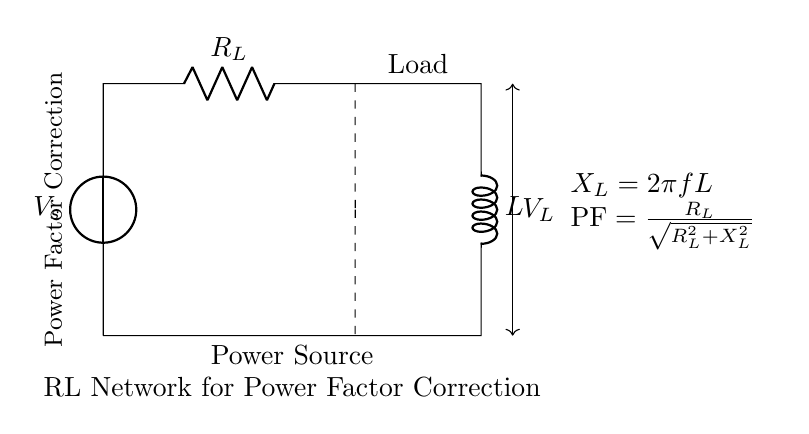What is the source voltage in this circuit? The source voltage is represented as V_s in the circuit diagram. It is the voltage supplied to the entire RL network.
Answer: V_s What component is used for power factor correction? The inductor (L) is used for power factor correction by compensating for the reactance in the circuit, thus improving the overall power factor.
Answer: L What is the relationship between the resistor and inductor in terms of power factor? The power factor is calculated using the formula PF = R_L / sqrt(R_L^2 + X_L^2). This indicates that the power factor depends on both the resistance and the inductive reactance.
Answer: PF = R_L / sqrt(R_L^2 + X_L^2) What does X_L represent in this circuit? X_L represents the inductive reactance, calculated as X_L = 2πfL, which describes the opposition to the flow of alternating current by the inductor.
Answer: X_L What is the voltage across the load denoted as? The voltage across the load is denoted as V_L in the circuit diagram, indicating the potential difference across the load resistance.
Answer: V_L What type of network is depicted in this circuit? The circuit depicts an RL network, which consists of a resistor and an inductor used together for power factor correction in large-scale computing systems.
Answer: RL Network 